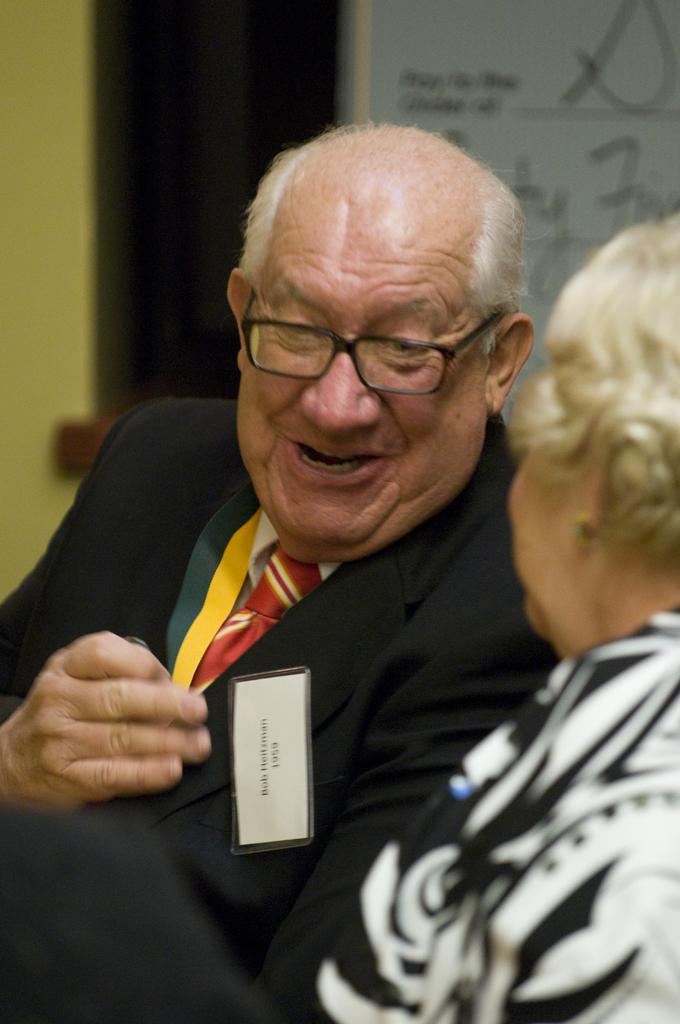What is the gender of the person on the right side of the image? There is a woman on the right side of the image. What is the person in the middle of the image wearing? The person in the middle of the image is wearing a black suit. What is the person in the black suit doing? The person in the black suit is talking. How would you describe the background of the image? The background of the image is blurred. What type of zebra can be seen in the image? There is no zebra present in the image. What is the person in the black suit saying as a good-bye message? The image does not provide any information about the content of the conversation, so we cannot determine if the person in the black suit is saying a good-bye message. 